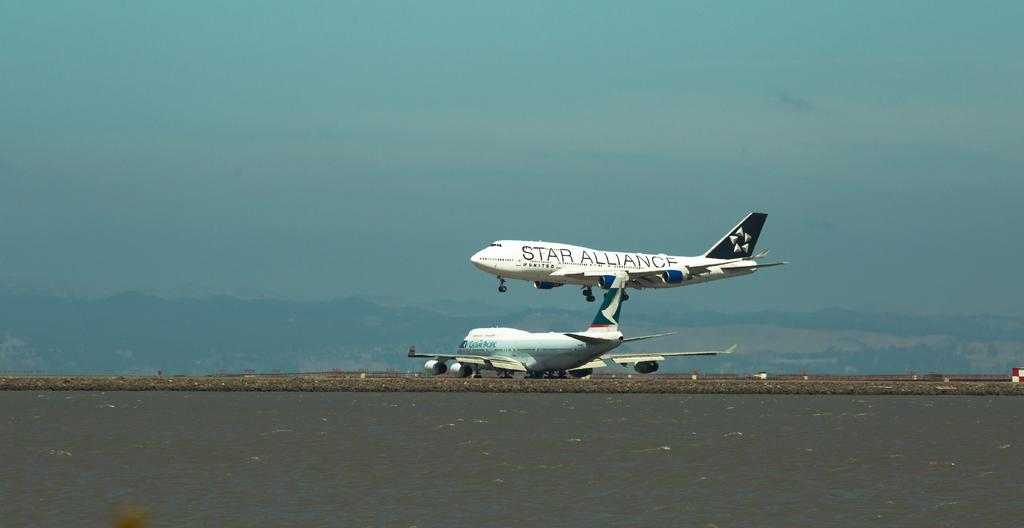How many airplanes are in the image? There are two airplanes in the image. What is the position of the first airplane? One airplane is on the surface. What is the position of the second airplane? The other airplane is in the air. What can be seen in the background of the image? The sky is visible in the background of the image. What type of rabbit can be seen wearing a badge on the arm of the airplane in the image? There is no rabbit or badge present on the arm of the airplane in the image. 